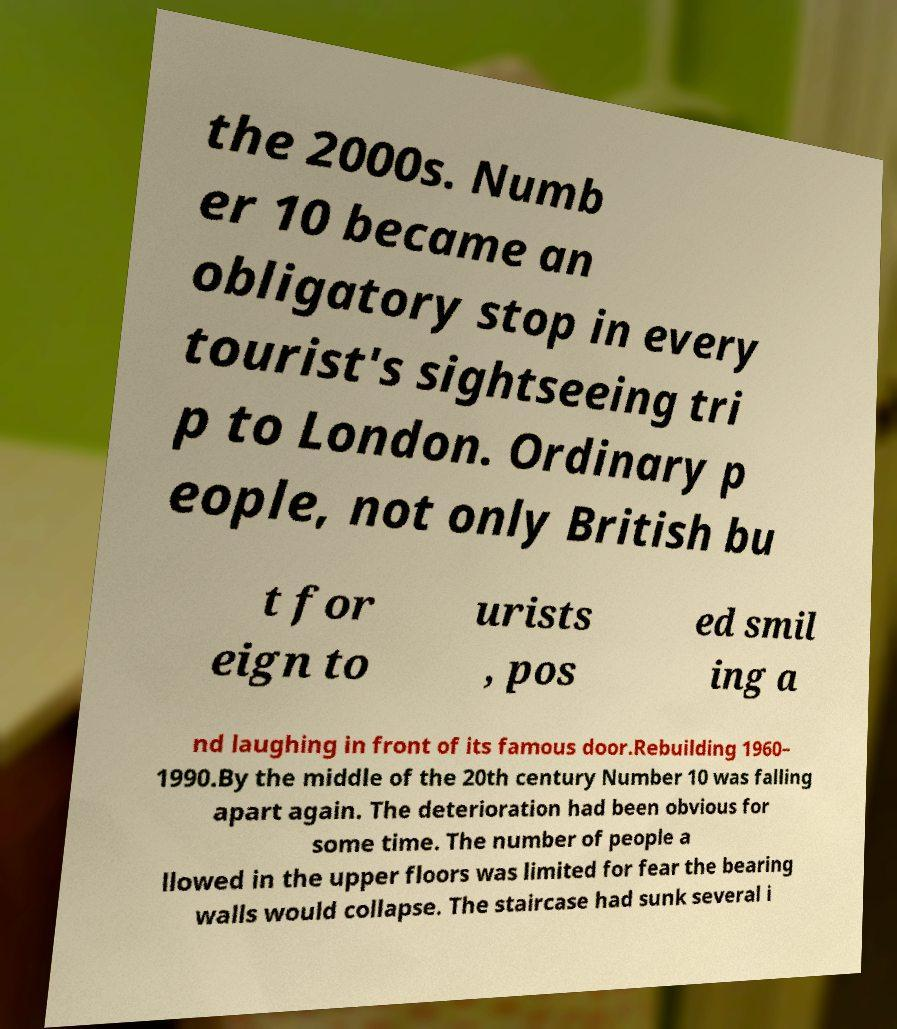For documentation purposes, I need the text within this image transcribed. Could you provide that? the 2000s. Numb er 10 became an obligatory stop in every tourist's sightseeing tri p to London. Ordinary p eople, not only British bu t for eign to urists , pos ed smil ing a nd laughing in front of its famous door.Rebuilding 1960– 1990.By the middle of the 20th century Number 10 was falling apart again. The deterioration had been obvious for some time. The number of people a llowed in the upper floors was limited for fear the bearing walls would collapse. The staircase had sunk several i 